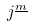Convert formula to latex. <formula><loc_0><loc_0><loc_500><loc_500>j ^ { \underline { m } }</formula> 